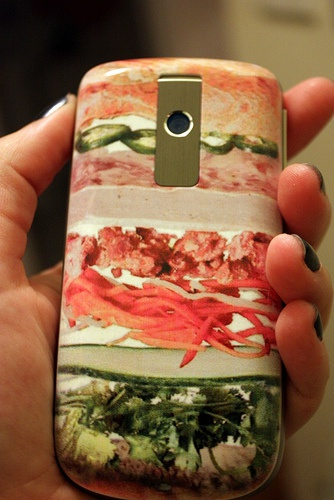Describe the objects in this image and their specific colors. I can see cell phone in black, tan, and olive tones, people in black, maroon, and brown tones, carrot in black, salmon, red, and brown tones, carrot in black, salmon, and red tones, and carrot in black, salmon, and red tones in this image. 